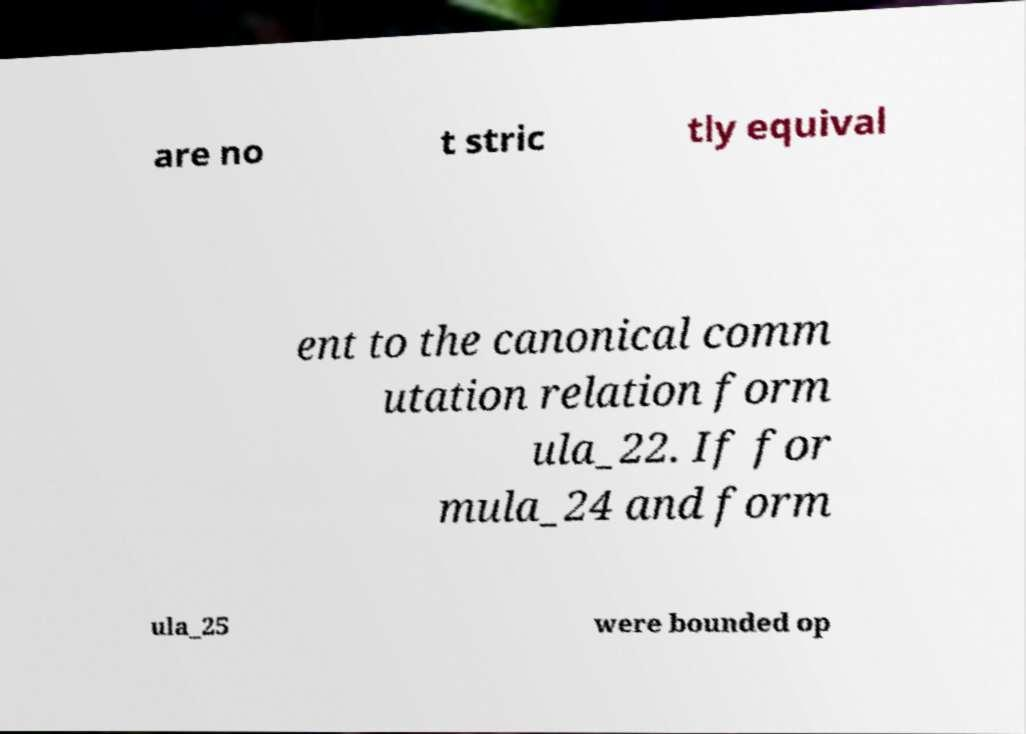Can you read and provide the text displayed in the image?This photo seems to have some interesting text. Can you extract and type it out for me? are no t stric tly equival ent to the canonical comm utation relation form ula_22. If for mula_24 and form ula_25 were bounded op 